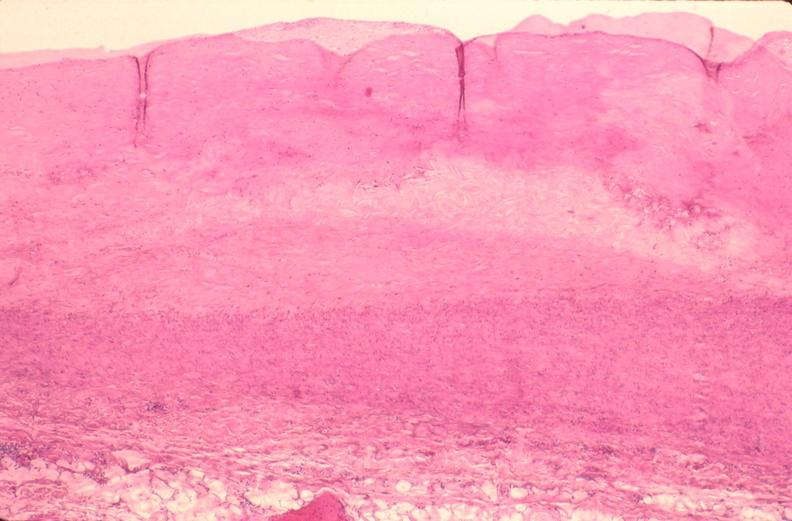what is present?
Answer the question using a single word or phrase. Cardiovascular 